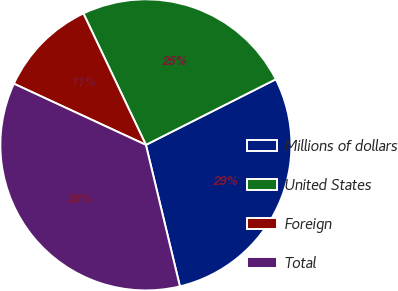<chart> <loc_0><loc_0><loc_500><loc_500><pie_chart><fcel>Millions of dollars<fcel>United States<fcel>Foreign<fcel>Total<nl><fcel>28.69%<fcel>24.62%<fcel>11.03%<fcel>35.66%<nl></chart> 